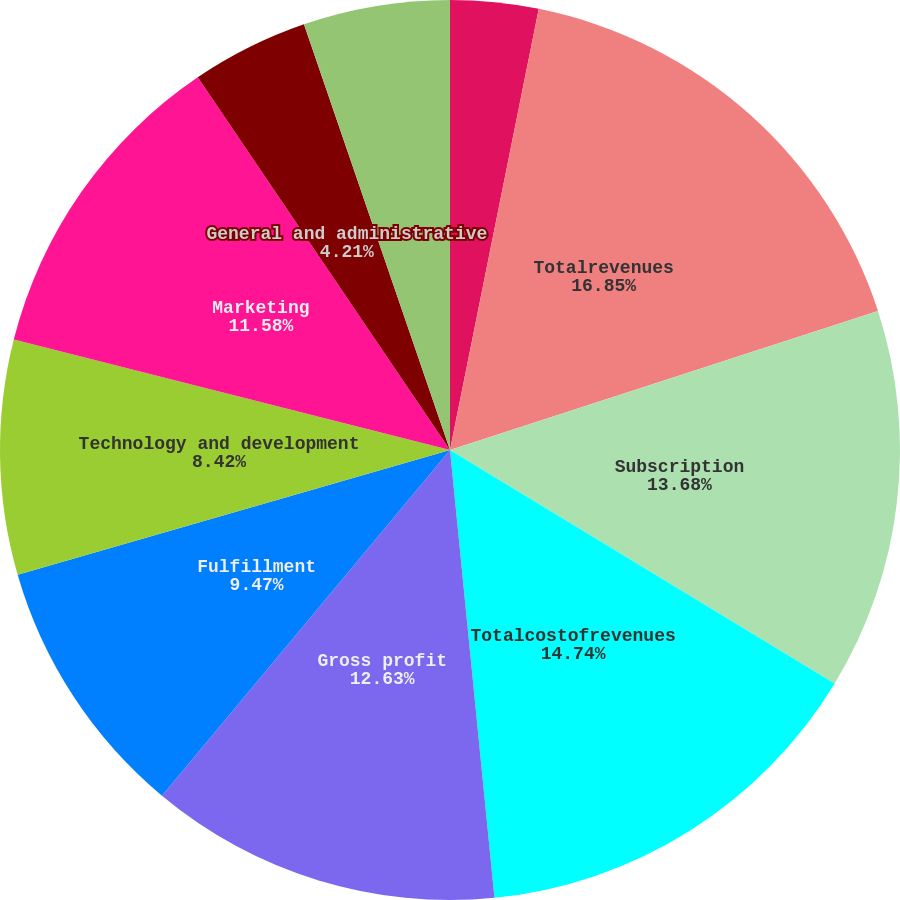<chart> <loc_0><loc_0><loc_500><loc_500><pie_chart><fcel>Sales<fcel>Totalrevenues<fcel>Subscription<fcel>Totalcostofrevenues<fcel>Gross profit<fcel>Fulfillment<fcel>Technology and development<fcel>Marketing<fcel>General and administrative<fcel>Stock-based compensation<nl><fcel>3.16%<fcel>16.84%<fcel>13.68%<fcel>14.74%<fcel>12.63%<fcel>9.47%<fcel>8.42%<fcel>11.58%<fcel>4.21%<fcel>5.26%<nl></chart> 